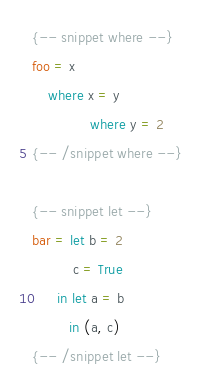Convert code to text. <code><loc_0><loc_0><loc_500><loc_500><_Haskell_>{-- snippet where --}
foo = x
    where x = y
              where y = 2
{-- /snippet where --}

{-- snippet let --}
bar = let b = 2
          c = True
      in let a = b
         in (a, c)
{-- /snippet let --}
</code> 